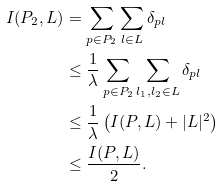Convert formula to latex. <formula><loc_0><loc_0><loc_500><loc_500>I ( P _ { 2 } , L ) & = \sum _ { p \in P _ { 2 } } \sum _ { l \in L } \delta _ { p l } \\ & \leq \frac { 1 } { \lambda } \sum _ { p \in P _ { 2 } } \sum _ { l _ { 1 } , l _ { 2 } \in L } \delta _ { p l } \\ & \leq \frac { 1 } { \lambda } \left ( I ( P , L ) + | L | ^ { 2 } \right ) \\ & \leq \frac { I ( P , L ) } { 2 } .</formula> 